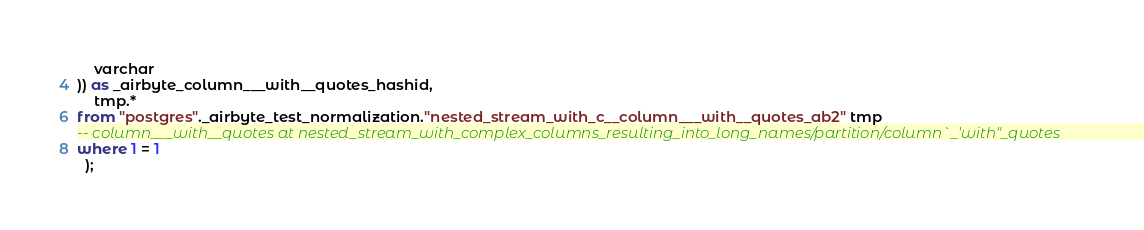<code> <loc_0><loc_0><loc_500><loc_500><_SQL_>    varchar
)) as _airbyte_column___with__quotes_hashid,
    tmp.*
from "postgres"._airbyte_test_normalization."nested_stream_with_c__column___with__quotes_ab2" tmp
-- column___with__quotes at nested_stream_with_complex_columns_resulting_into_long_names/partition/column`_'with"_quotes
where 1 = 1
  );
</code> 